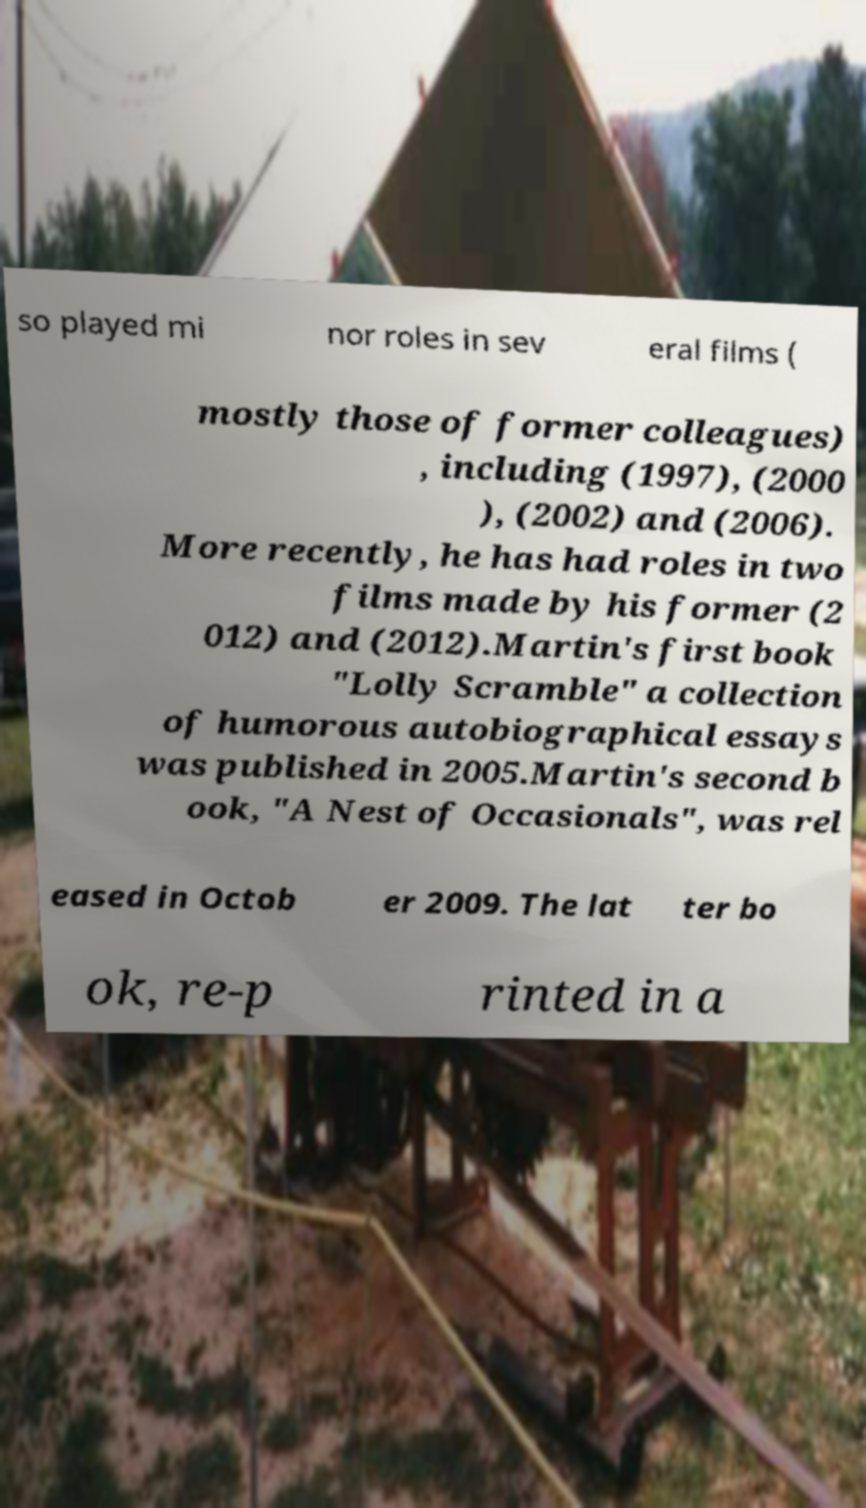Can you read and provide the text displayed in the image?This photo seems to have some interesting text. Can you extract and type it out for me? so played mi nor roles in sev eral films ( mostly those of former colleagues) , including (1997), (2000 ), (2002) and (2006). More recently, he has had roles in two films made by his former (2 012) and (2012).Martin's first book "Lolly Scramble" a collection of humorous autobiographical essays was published in 2005.Martin's second b ook, "A Nest of Occasionals", was rel eased in Octob er 2009. The lat ter bo ok, re-p rinted in a 